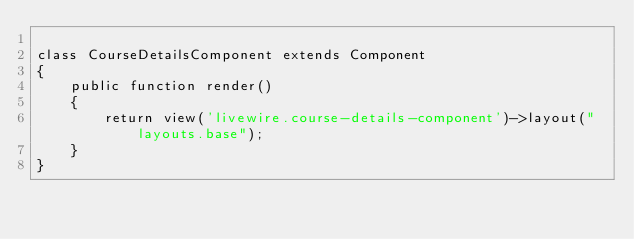Convert code to text. <code><loc_0><loc_0><loc_500><loc_500><_PHP_>
class CourseDetailsComponent extends Component
{
    public function render()
    {
        return view('livewire.course-details-component')->layout("layouts.base");
    }
}
</code> 